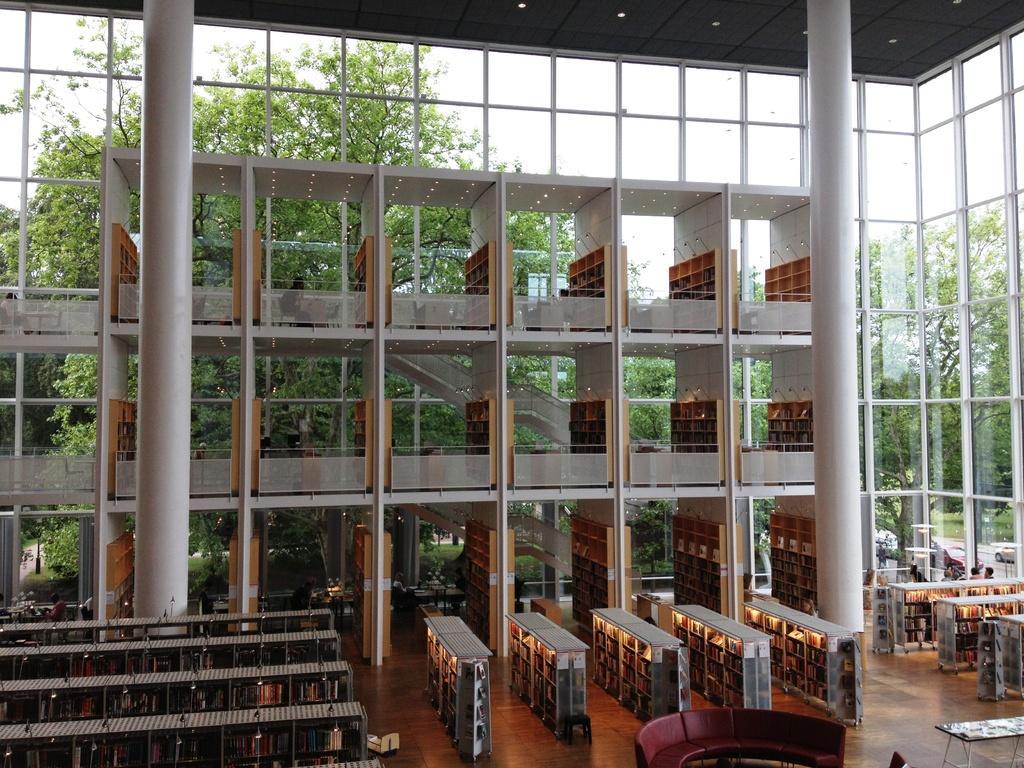How would you summarize this image in a sentence or two? In this picture we can see an inside view of a building, here we can see pillars, floor, people and some objects and in the background we can see trees, vehicles, sky. 